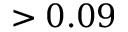Convert formula to latex. <formula><loc_0><loc_0><loc_500><loc_500>> 0 . 0 9</formula> 